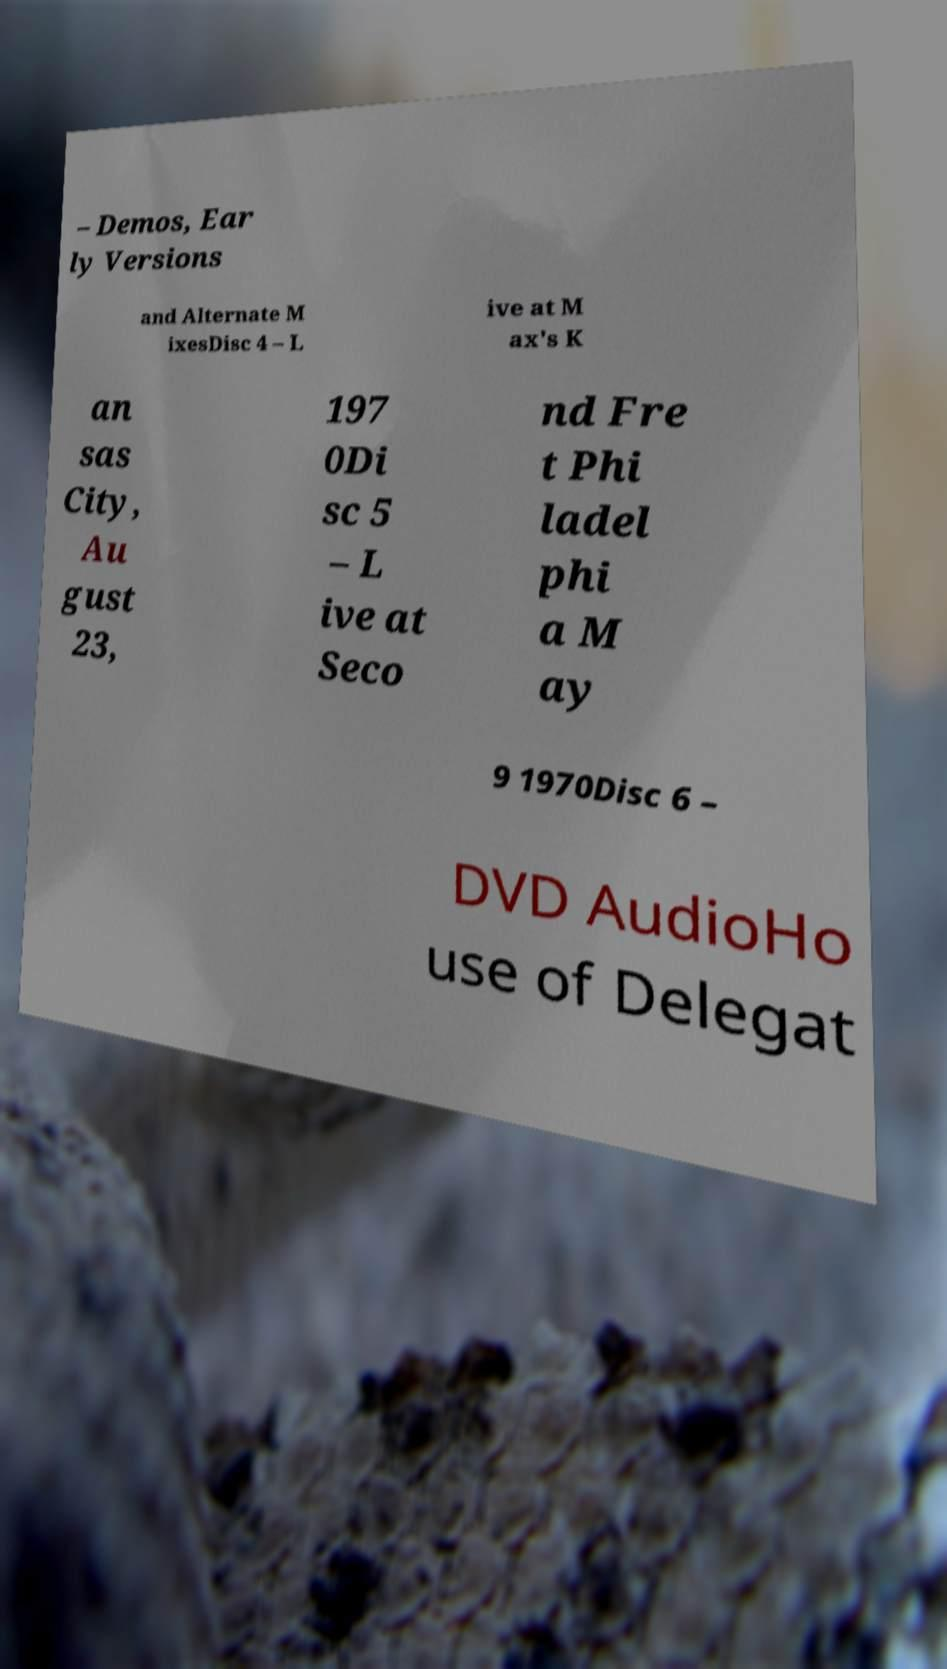Can you accurately transcribe the text from the provided image for me? – Demos, Ear ly Versions and Alternate M ixesDisc 4 – L ive at M ax's K an sas City, Au gust 23, 197 0Di sc 5 – L ive at Seco nd Fre t Phi ladel phi a M ay 9 1970Disc 6 – DVD AudioHo use of Delegat 